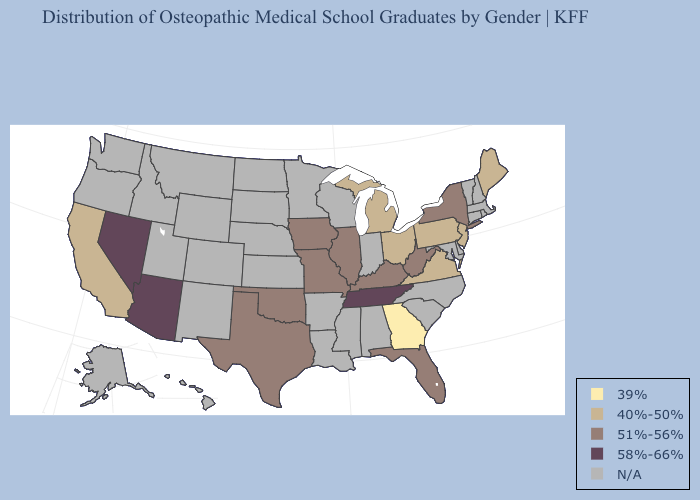What is the lowest value in states that border Colorado?
Be succinct. 51%-56%. How many symbols are there in the legend?
Give a very brief answer. 5. Does Iowa have the lowest value in the MidWest?
Answer briefly. No. Does Arizona have the highest value in the USA?
Short answer required. Yes. What is the value of South Carolina?
Give a very brief answer. N/A. Name the states that have a value in the range N/A?
Keep it brief. Alabama, Alaska, Arkansas, Colorado, Connecticut, Delaware, Hawaii, Idaho, Indiana, Kansas, Louisiana, Maryland, Massachusetts, Minnesota, Mississippi, Montana, Nebraska, New Hampshire, New Mexico, North Carolina, North Dakota, Oregon, Rhode Island, South Carolina, South Dakota, Utah, Vermont, Washington, Wisconsin, Wyoming. Does West Virginia have the lowest value in the South?
Answer briefly. No. Does the first symbol in the legend represent the smallest category?
Short answer required. Yes. Among the states that border Minnesota , which have the lowest value?
Give a very brief answer. Iowa. Among the states that border Nevada , does Arizona have the highest value?
Write a very short answer. Yes. Name the states that have a value in the range 58%-66%?
Quick response, please. Arizona, Nevada, Tennessee. Name the states that have a value in the range 39%?
Write a very short answer. Georgia. Among the states that border West Virginia , which have the highest value?
Answer briefly. Kentucky. Name the states that have a value in the range 39%?
Write a very short answer. Georgia. Among the states that border Illinois , which have the highest value?
Quick response, please. Iowa, Kentucky, Missouri. 